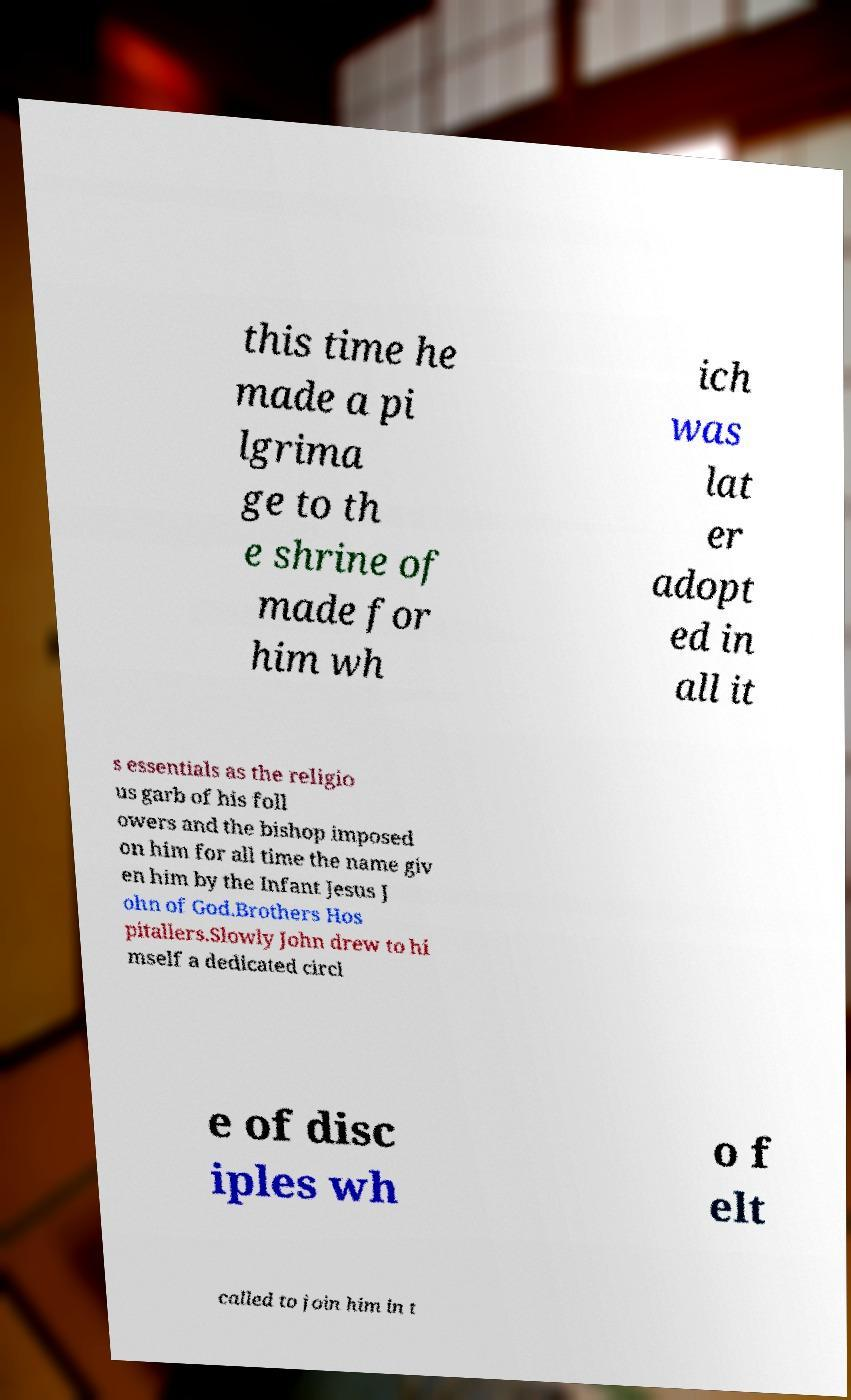There's text embedded in this image that I need extracted. Can you transcribe it verbatim? this time he made a pi lgrima ge to th e shrine of made for him wh ich was lat er adopt ed in all it s essentials as the religio us garb of his foll owers and the bishop imposed on him for all time the name giv en him by the Infant Jesus J ohn of God.Brothers Hos pitallers.Slowly John drew to hi mself a dedicated circl e of disc iples wh o f elt called to join him in t 